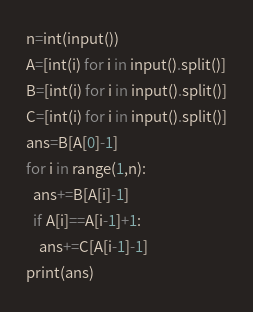<code> <loc_0><loc_0><loc_500><loc_500><_Python_>n=int(input())
A=[int(i) for i in input().split()]
B=[int(i) for i in input().split()]
C=[int(i) for i in input().split()]
ans=B[A[0]-1]
for i in range(1,n):
  ans+=B[A[i]-1]
  if A[i]==A[i-1]+1:
    ans+=C[A[i-1]-1]
print(ans)
</code> 